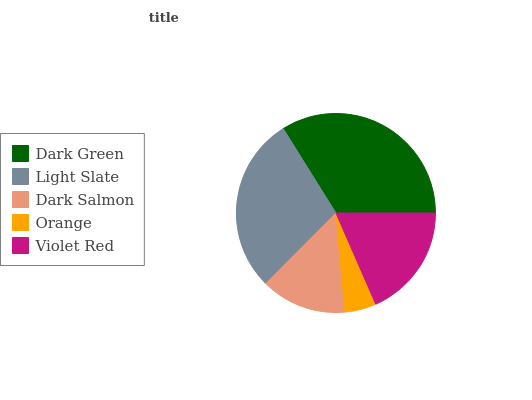Is Orange the minimum?
Answer yes or no. Yes. Is Dark Green the maximum?
Answer yes or no. Yes. Is Light Slate the minimum?
Answer yes or no. No. Is Light Slate the maximum?
Answer yes or no. No. Is Dark Green greater than Light Slate?
Answer yes or no. Yes. Is Light Slate less than Dark Green?
Answer yes or no. Yes. Is Light Slate greater than Dark Green?
Answer yes or no. No. Is Dark Green less than Light Slate?
Answer yes or no. No. Is Violet Red the high median?
Answer yes or no. Yes. Is Violet Red the low median?
Answer yes or no. Yes. Is Light Slate the high median?
Answer yes or no. No. Is Light Slate the low median?
Answer yes or no. No. 